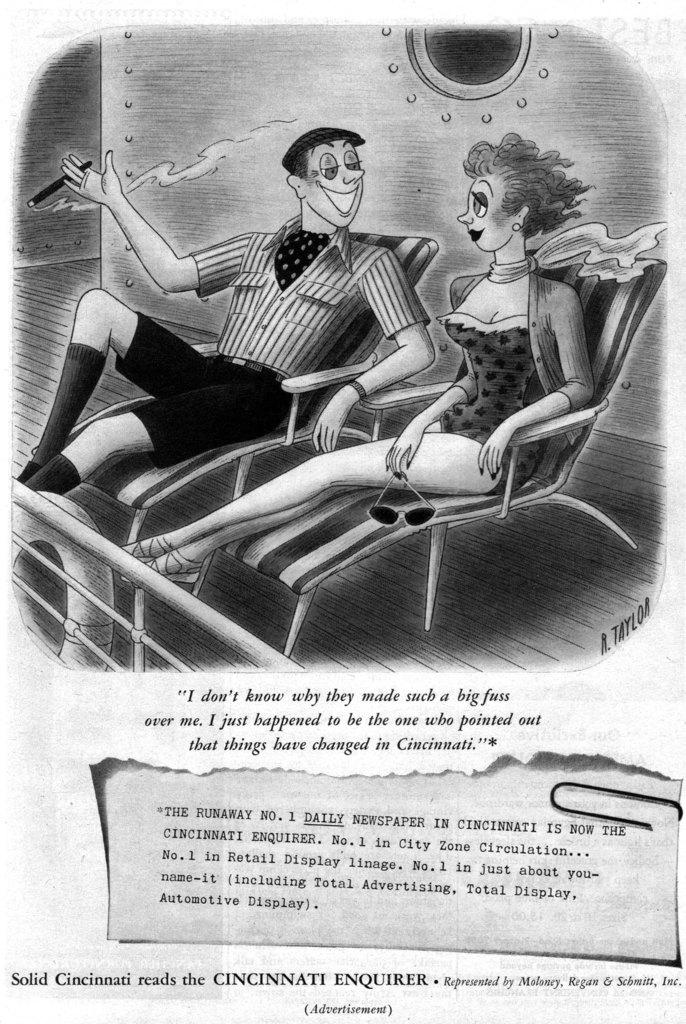What type of image is being described? The image is a newspaper column. What is featured within the newspaper column? There is a cartoon in the image. Can you describe the scene depicted in the cartoon? The cartoon depicts two people sitting in beach chairs. Is there any text accompanying the cartoon? Yes, there is text at the bottom of the image. What type of protest is happening on the street in the image? There is no protest or street present in the image; it is a newspaper column featuring a cartoon with two people sitting in beach chairs. 